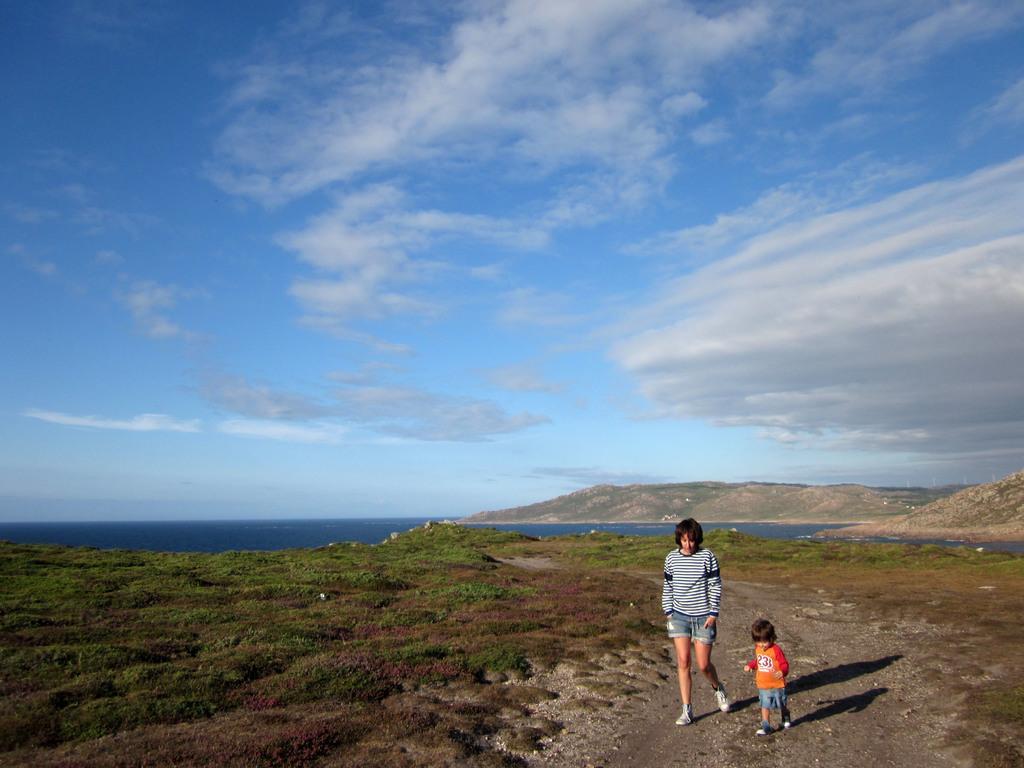Could you give a brief overview of what you see in this image? In this image we can see a person and a child. On the ground there is grass. In the background there is water. Also there is hill. And there is sky with clouds. 